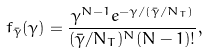<formula> <loc_0><loc_0><loc_500><loc_500>f _ { \bar { \gamma } } ( \gamma ) = \frac { \gamma ^ { N - 1 } e ^ { - \gamma / ( \bar { \gamma } / N _ { T } ) } } { ( \bar { \gamma } / N _ { T } ) ^ { N } ( N - 1 ) ! } ,</formula> 